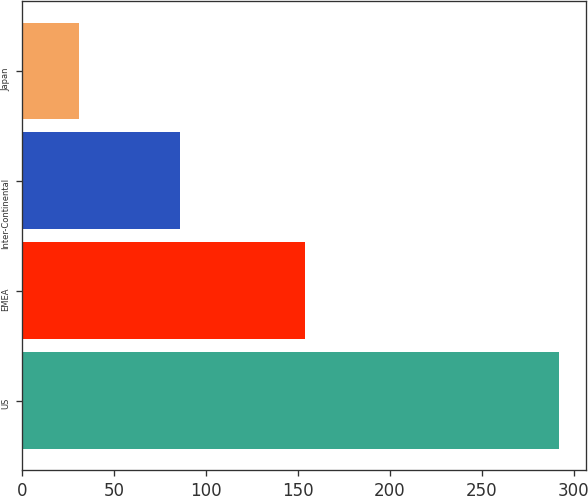Convert chart. <chart><loc_0><loc_0><loc_500><loc_500><bar_chart><fcel>US<fcel>EMEA<fcel>Inter-Continental<fcel>Japan<nl><fcel>292<fcel>154<fcel>86<fcel>31<nl></chart> 